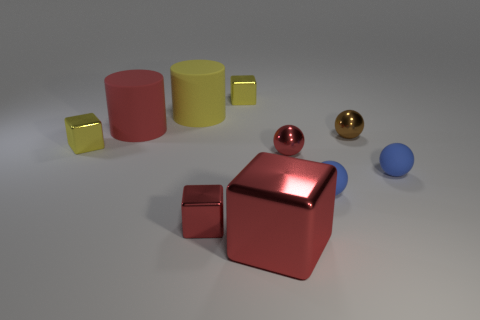Subtract all big metallic blocks. How many blocks are left? 3 Subtract all cubes. How many objects are left? 6 Subtract all red cubes. How many cubes are left? 2 Subtract 2 spheres. How many spheres are left? 2 Subtract all red cylinders. How many red blocks are left? 2 Subtract all green balls. Subtract all yellow blocks. How many balls are left? 4 Subtract all small matte spheres. Subtract all red rubber things. How many objects are left? 7 Add 8 large metal things. How many large metal things are left? 9 Add 1 tiny green matte balls. How many tiny green matte balls exist? 1 Subtract 0 brown blocks. How many objects are left? 10 